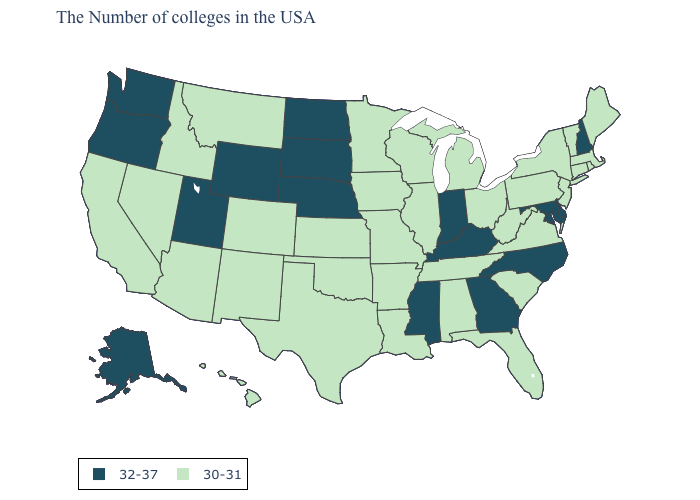What is the value of Louisiana?
Short answer required. 30-31. What is the highest value in states that border Pennsylvania?
Give a very brief answer. 32-37. Among the states that border California , which have the highest value?
Short answer required. Oregon. What is the value of Iowa?
Be succinct. 30-31. What is the highest value in the South ?
Be succinct. 32-37. Is the legend a continuous bar?
Quick response, please. No. Name the states that have a value in the range 32-37?
Be succinct. New Hampshire, Delaware, Maryland, North Carolina, Georgia, Kentucky, Indiana, Mississippi, Nebraska, South Dakota, North Dakota, Wyoming, Utah, Washington, Oregon, Alaska. Does Indiana have the highest value in the MidWest?
Write a very short answer. Yes. Name the states that have a value in the range 30-31?
Write a very short answer. Maine, Massachusetts, Rhode Island, Vermont, Connecticut, New York, New Jersey, Pennsylvania, Virginia, South Carolina, West Virginia, Ohio, Florida, Michigan, Alabama, Tennessee, Wisconsin, Illinois, Louisiana, Missouri, Arkansas, Minnesota, Iowa, Kansas, Oklahoma, Texas, Colorado, New Mexico, Montana, Arizona, Idaho, Nevada, California, Hawaii. What is the highest value in states that border South Dakota?
Give a very brief answer. 32-37. How many symbols are there in the legend?
Quick response, please. 2. How many symbols are there in the legend?
Give a very brief answer. 2. What is the value of Texas?
Write a very short answer. 30-31. Does New Mexico have a lower value than Mississippi?
Be succinct. Yes. Name the states that have a value in the range 32-37?
Be succinct. New Hampshire, Delaware, Maryland, North Carolina, Georgia, Kentucky, Indiana, Mississippi, Nebraska, South Dakota, North Dakota, Wyoming, Utah, Washington, Oregon, Alaska. 